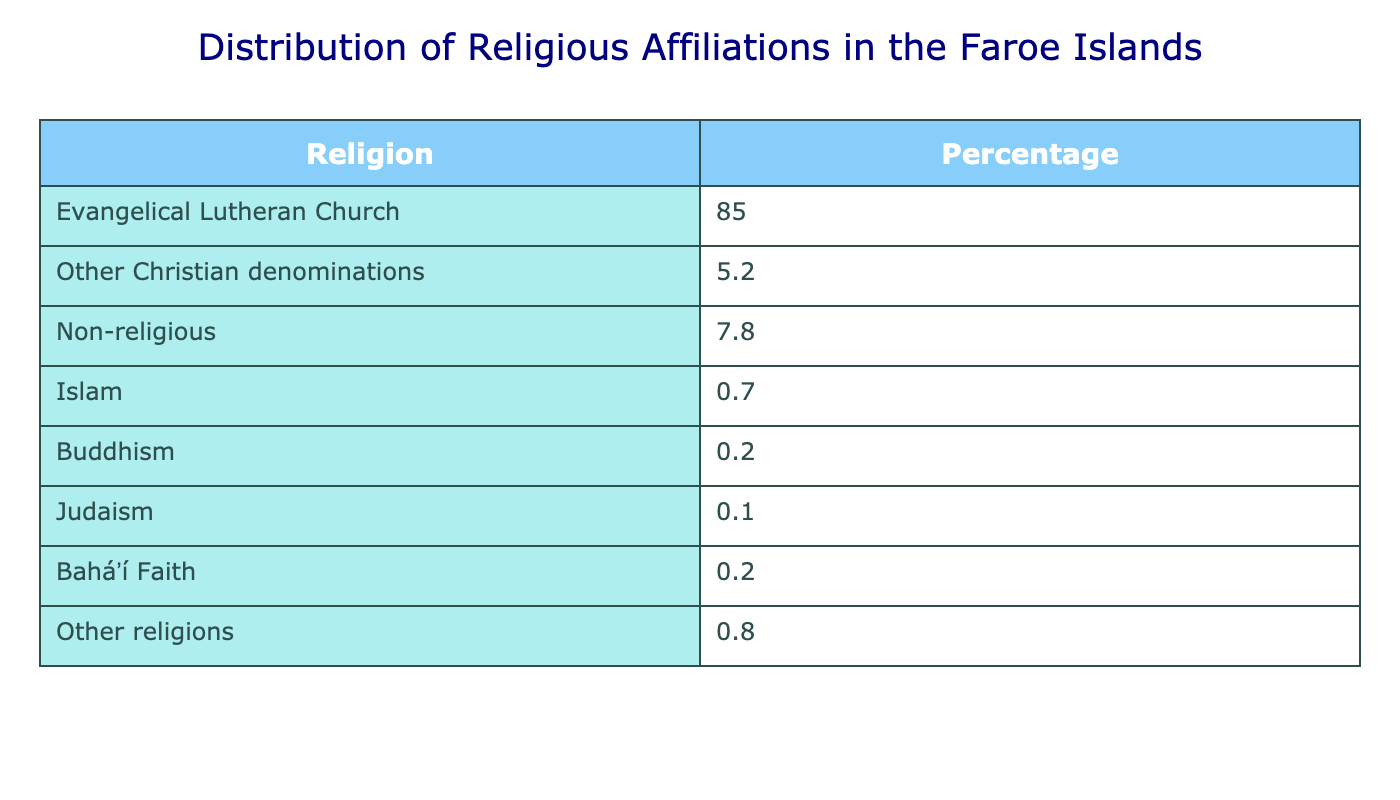What percentage of the population belongs to the Evangelical Lutheran Church? The table shows that the Evangelical Lutheran Church has a percentage of 85.0% of the population in the Faroe Islands.
Answer: 85.0% What is the percentage of people who identify as non-religious? According to the table, 7.8% of the population identifies as non-religious.
Answer: 7.8% How many religious affiliations have a percentage of less than 1%? The table lists Islam (0.7%), Buddhism (0.2%), Judaism (0.1%), and Baháʼí Faith (0.2%), totaling 4 religions with less than 1%.
Answer: 4 What is the combined percentage of other Christian denominations and non-religious people? The percentage of other Christian denominations is 5.2% and non-religious is 7.8%. Adding these together gives 5.2% + 7.8% = 13.0%.
Answer: 13.0% Is it true that Islam and Buddhism together account for more than 1% of the population? Islam accounts for 0.7% and Buddhism accounts for 0.2%, leading to a total of 0.7% + 0.2% = 0.9%, which is less than 1%. Therefore, the statement is false.
Answer: No What percentage of the population follows religions other than Evangelical Lutheran Church? The combined percentage of other Christian denominations, non-religious, Islam, Buddhism, Judaism, Baháʼí Faith, and other religions is calculated as 5.2% + 7.8% + 0.7% + 0.2% + 0.1% + 0.2% + 0.8% = 15.0%.
Answer: 15.0% What religion has the second largest percentage after the Evangelical Lutheran Church? The category that follows the Evangelical Lutheran Church is "Other Christian denominations" with 5.2%.
Answer: Other Christian denominations If you take the average percentage of all religions listed, what would it be? To find the average, we first sum all percentages: 85.0 + 5.2 + 7.8 + 0.7 + 0.2 + 0.1 + 0.2 + 0.8 = 99.0%. Since there are 8 entries, the average is 99.0% / 8 = 12.375%.
Answer: 12.375% Which religious affiliation has the lowest percentage? The lowest percentage in the table is Judaism, which has a percentage of 0.1%.
Answer: Judaism What percentage of the population follows religions other than the evangelical Lutheran Church and non-religious? To find this, add the percentages for Other Christian denominations (5.2%), Islam (0.7%), Buddhism (0.2%), Judaism (0.1%), Baháʼí Faith (0.2%), and Other religions (0.8%). The total is 5.2 + 0.7 + 0.2 + 0.1 + 0.2 + 0.8 = 7.2%.
Answer: 7.2% 